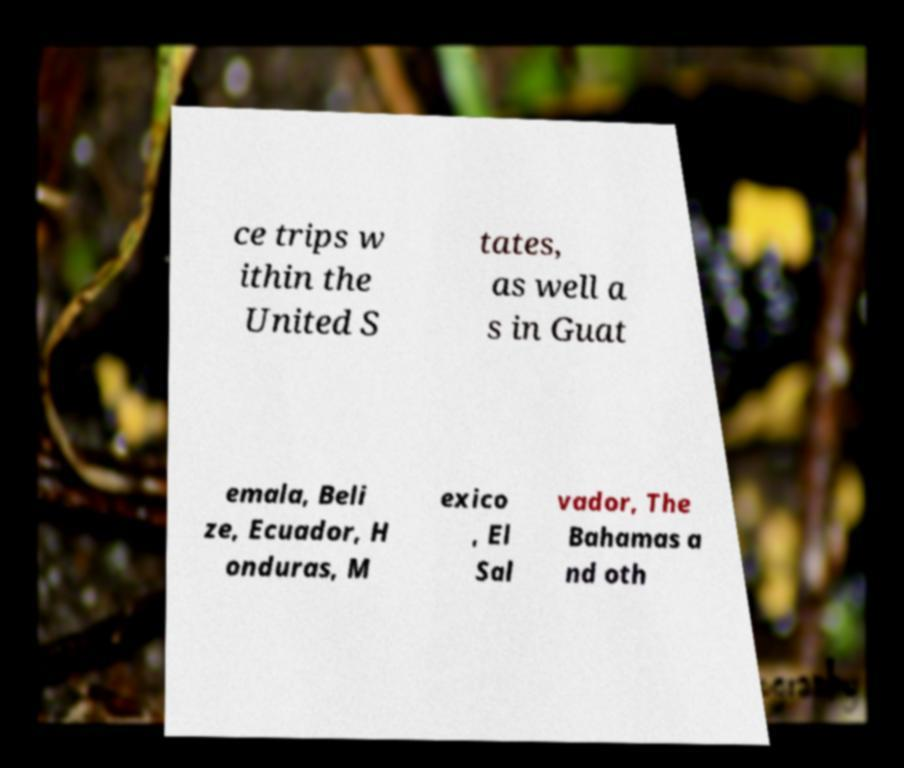Could you assist in decoding the text presented in this image and type it out clearly? ce trips w ithin the United S tates, as well a s in Guat emala, Beli ze, Ecuador, H onduras, M exico , El Sal vador, The Bahamas a nd oth 